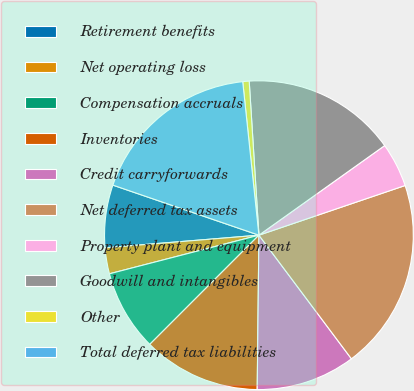<chart> <loc_0><loc_0><loc_500><loc_500><pie_chart><fcel>Retirement benefits<fcel>Net operating loss<fcel>Compensation accruals<fcel>Inventories<fcel>Credit carryforwards<fcel>Net deferred tax assets<fcel>Property plant and equipment<fcel>Goodwill and intangibles<fcel>Other<fcel>Total deferred tax liabilities<nl><fcel>6.56%<fcel>2.72%<fcel>8.48%<fcel>12.32%<fcel>10.4%<fcel>19.99%<fcel>4.64%<fcel>16.15%<fcel>0.67%<fcel>18.07%<nl></chart> 